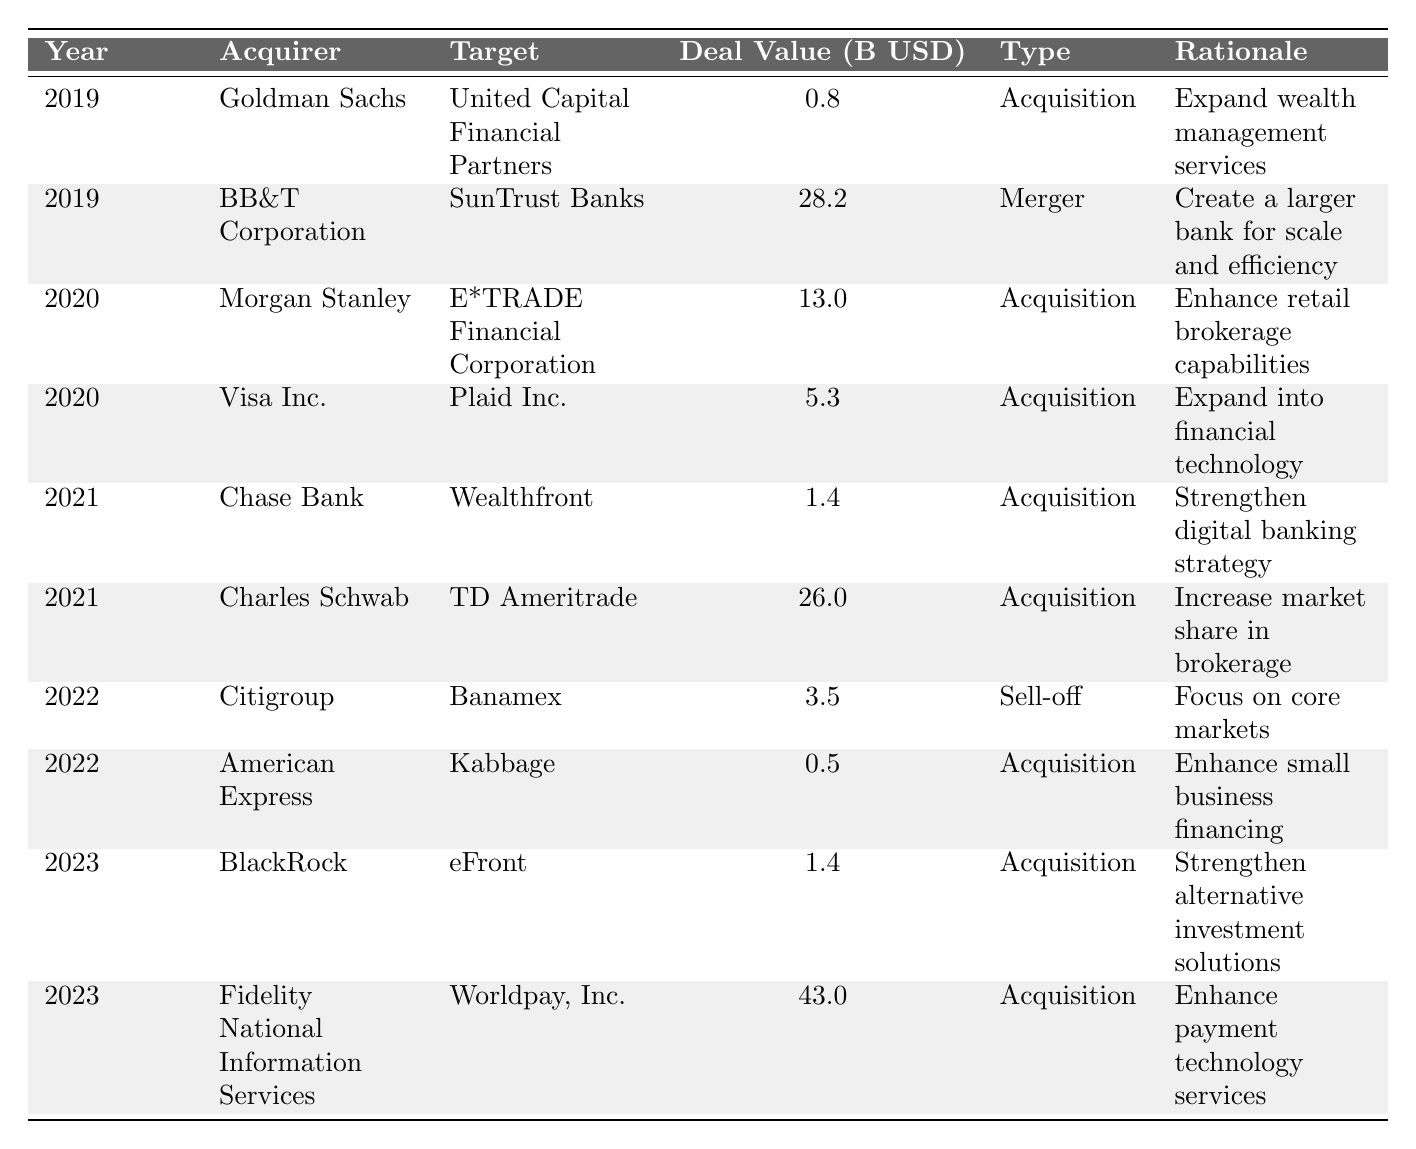What was the largest deal value in 2023? In 2023, the acquisition by Fidelity National Information Services of Worldpay, Inc. has the largest deal value at 43.0 billion USD.
Answer: 43.0 billion USD How many mergers occurred in 2019? In 2019, there is one merger listed: BB&T Corporation's merger with SunTrust Banks.
Answer: 1 What was the rationale for Goldman Sachs' acquisition in 2019? The rationale for Goldman Sachs' acquisition of United Capital Financial Partners in 2019 was to expand wealth management services.
Answer: Expand wealth management services Which acquirer had the highest cumulative deal value across all years? Calculating the total deal values: Goldman Sachs (0.8), BB&T Corporation (28.2), Morgan Stanley (13.0), Visa Inc. (5.3), Chase Bank (1.4), Charles Schwab (26.0), Citigroup (3.5), American Express (0.5), BlackRock (1.4), Fidelity National Information Services (43.0). The total for Fidelity National Information Services is the highest at 43.0 billion USD from only one deal, but cumulatively, BB&T Corporation has the highest cumulative value at 28.2 billion USD from one merger, and Charles Schwab accumulates 26.0 from one deal leading it second highest with only the acquisition of TD Ameritrade. Therefore, the highest cumulative is BB&T Corporation.
Answer: BB&T Corporation What type of deal was categorized most frequently in this data set? Upon reviewing the table, there are more acquisitions (six instances) compared to mergers (two instances) and one sell-off. Thus, acquisitions are the most frequently occurring deal type.
Answer: Acquisitions Did Citigroup's deal in 2022 result in an increase in its market assets? No, Citigroup's deal with Banamex was a sell-off to focus on core markets, indicating a reduction in market assets rather than an increase.
Answer: No What was the average deal value for acquisitions made in 2021? The deal values for acquisitions in 2021 are 1.4 billion USD (Chase Bank) and 26.0 billion USD (Charles Schwab). The average is (1.4 + 26.0) / 2 = 13.7 billion USD.
Answer: 13.7 billion USD Which company had a deal focus on technology acquisition and in what year? Visa Inc. focused on technology acquisition by acquiring Plaid Inc. in the year 2020.
Answer: Visa Inc. in 2020 What percentage of the total deal values from 2019 to 2023 were from mergers? Summing all deal values gives: 0.8 + 28.2 + 13.0 + 5.3 + 1.4 + 26.0 + 3.5 + 0.5 + 1.4 + 43.0 = 123.1 billion USD. The merger (BB&T Corporation) is at 28.2 billion USD, which is 28.2 / 123.1 = 0.2291 or approximately 22.91%.
Answer: Approximately 22.91% Which year had the highest total deal value and what was that value? Summing the deal values by year shows 2019 (29.0), 2020 (18.3), 2021 (27.4), 2022 (4.0), and 2023 (44.4). The year with the highest total deal value is 2023 with 44.4 billion USD.
Answer: 2023 with 44.4 billion USD What was the total number of unique acquirers in the years represented? The acquirers listed are Goldman Sachs, BB&T Corporation, Morgan Stanley, Visa Inc., Chase Bank, Charles Schwab, Citigroup, American Express, BlackRock, and Fidelity National Information Services. That totals to 10 unique acquirers.
Answer: 10 unique acquirers 